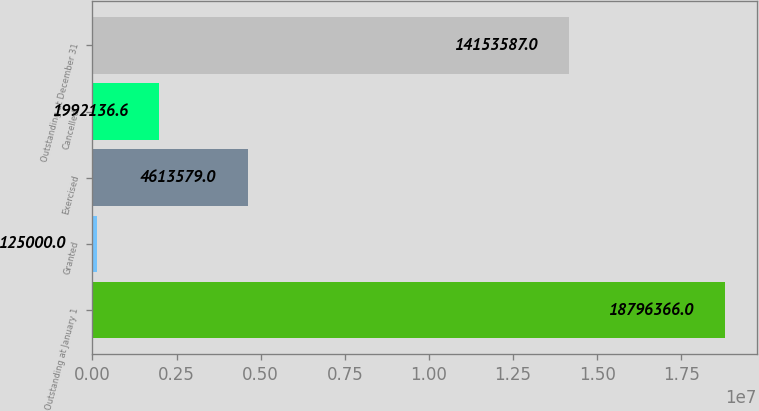<chart> <loc_0><loc_0><loc_500><loc_500><bar_chart><fcel>Outstanding at January 1<fcel>Granted<fcel>Exercised<fcel>Cancelled<fcel>Outstanding at December 31<nl><fcel>1.87964e+07<fcel>125000<fcel>4.61358e+06<fcel>1.99214e+06<fcel>1.41536e+07<nl></chart> 